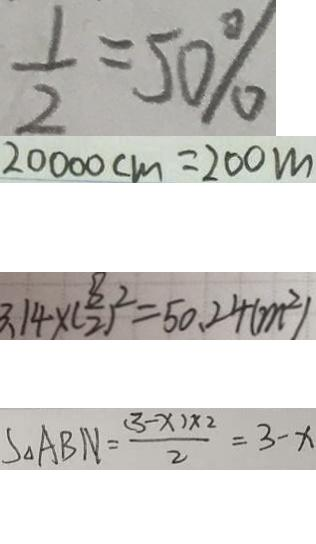Convert formula to latex. <formula><loc_0><loc_0><loc_500><loc_500>\frac { 1 } { 2 } = 5 0 \% 
 2 0 0 0 0 c m = 2 0 0 m 
 3 . 1 4 \times ( \frac { 8 } { 2 } ) ^ { 2 } = 5 0 . 2 4 ( m ^ { 2 } ) 
 S _ { \Delta } A B N = \frac { ( 3 - x ) \times 2 } { 2 } = 3 - x</formula> 